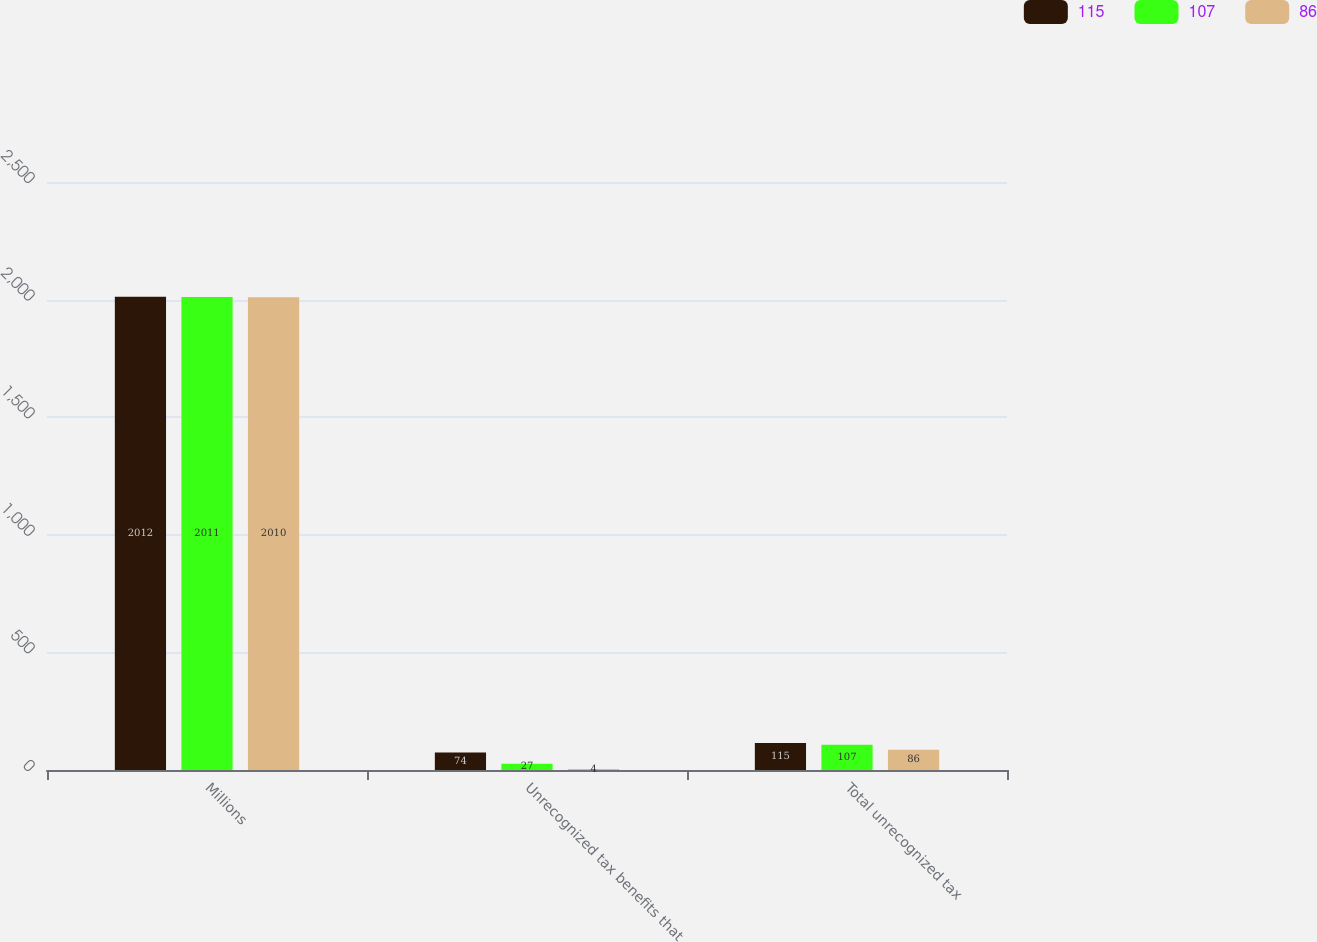<chart> <loc_0><loc_0><loc_500><loc_500><stacked_bar_chart><ecel><fcel>Millions<fcel>Unrecognized tax benefits that<fcel>Total unrecognized tax<nl><fcel>115<fcel>2012<fcel>74<fcel>115<nl><fcel>107<fcel>2011<fcel>27<fcel>107<nl><fcel>86<fcel>2010<fcel>4<fcel>86<nl></chart> 